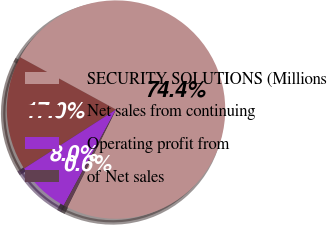Convert chart. <chart><loc_0><loc_0><loc_500><loc_500><pie_chart><fcel>SECURITY SOLUTIONS (Millions<fcel>Net sales from continuing<fcel>Operating profit from<fcel>of Net sales<nl><fcel>74.41%<fcel>17.02%<fcel>7.98%<fcel>0.59%<nl></chart> 